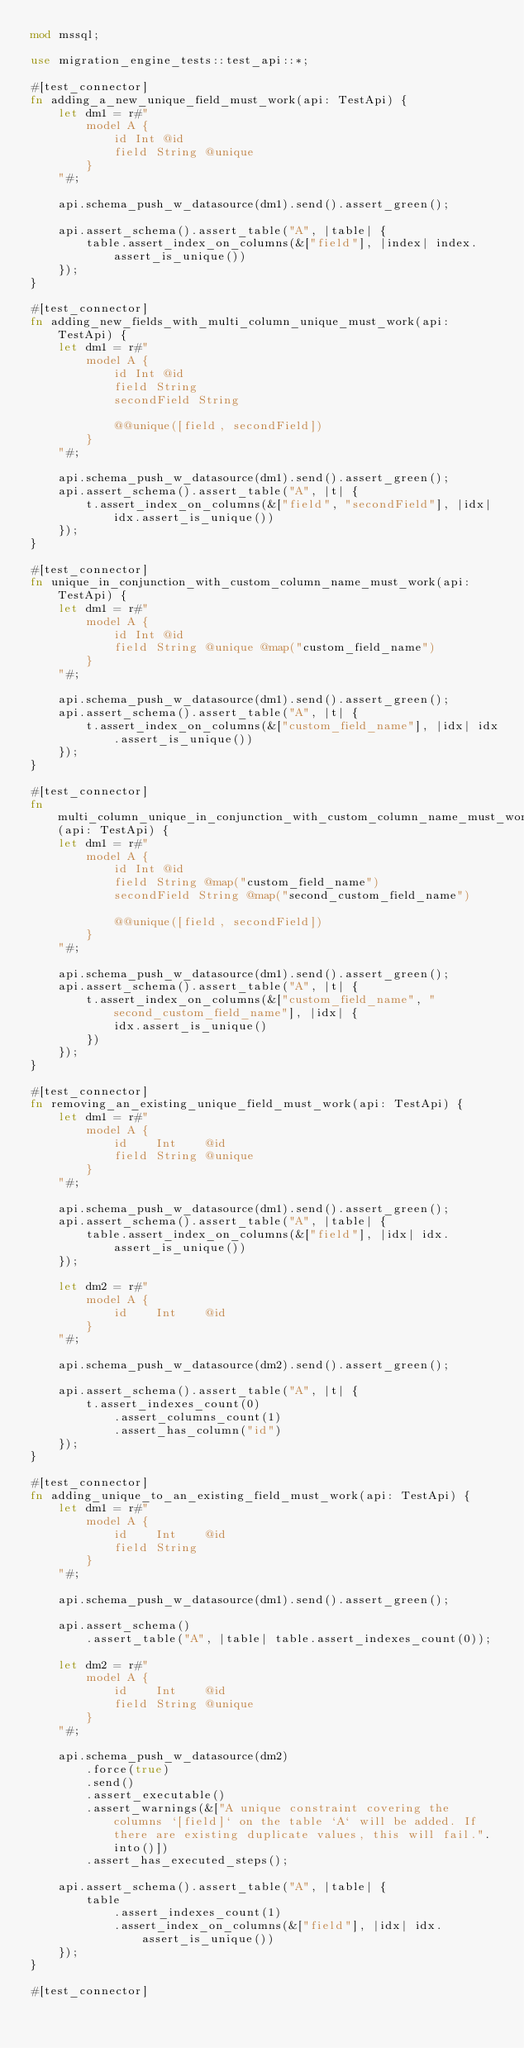Convert code to text. <code><loc_0><loc_0><loc_500><loc_500><_Rust_>mod mssql;

use migration_engine_tests::test_api::*;

#[test_connector]
fn adding_a_new_unique_field_must_work(api: TestApi) {
    let dm1 = r#"
        model A {
            id Int @id
            field String @unique
        }
    "#;

    api.schema_push_w_datasource(dm1).send().assert_green();

    api.assert_schema().assert_table("A", |table| {
        table.assert_index_on_columns(&["field"], |index| index.assert_is_unique())
    });
}

#[test_connector]
fn adding_new_fields_with_multi_column_unique_must_work(api: TestApi) {
    let dm1 = r#"
        model A {
            id Int @id
            field String
            secondField String

            @@unique([field, secondField])
        }
    "#;

    api.schema_push_w_datasource(dm1).send().assert_green();
    api.assert_schema().assert_table("A", |t| {
        t.assert_index_on_columns(&["field", "secondField"], |idx| idx.assert_is_unique())
    });
}

#[test_connector]
fn unique_in_conjunction_with_custom_column_name_must_work(api: TestApi) {
    let dm1 = r#"
        model A {
            id Int @id
            field String @unique @map("custom_field_name")
        }
    "#;

    api.schema_push_w_datasource(dm1).send().assert_green();
    api.assert_schema().assert_table("A", |t| {
        t.assert_index_on_columns(&["custom_field_name"], |idx| idx.assert_is_unique())
    });
}

#[test_connector]
fn multi_column_unique_in_conjunction_with_custom_column_name_must_work(api: TestApi) {
    let dm1 = r#"
        model A {
            id Int @id
            field String @map("custom_field_name")
            secondField String @map("second_custom_field_name")

            @@unique([field, secondField])
        }
    "#;

    api.schema_push_w_datasource(dm1).send().assert_green();
    api.assert_schema().assert_table("A", |t| {
        t.assert_index_on_columns(&["custom_field_name", "second_custom_field_name"], |idx| {
            idx.assert_is_unique()
        })
    });
}

#[test_connector]
fn removing_an_existing_unique_field_must_work(api: TestApi) {
    let dm1 = r#"
        model A {
            id    Int    @id
            field String @unique
        }
    "#;

    api.schema_push_w_datasource(dm1).send().assert_green();
    api.assert_schema().assert_table("A", |table| {
        table.assert_index_on_columns(&["field"], |idx| idx.assert_is_unique())
    });

    let dm2 = r#"
        model A {
            id    Int    @id
        }
    "#;

    api.schema_push_w_datasource(dm2).send().assert_green();

    api.assert_schema().assert_table("A", |t| {
        t.assert_indexes_count(0)
            .assert_columns_count(1)
            .assert_has_column("id")
    });
}

#[test_connector]
fn adding_unique_to_an_existing_field_must_work(api: TestApi) {
    let dm1 = r#"
        model A {
            id    Int    @id
            field String
        }
    "#;

    api.schema_push_w_datasource(dm1).send().assert_green();

    api.assert_schema()
        .assert_table("A", |table| table.assert_indexes_count(0));

    let dm2 = r#"
        model A {
            id    Int    @id
            field String @unique
        }
    "#;

    api.schema_push_w_datasource(dm2)
        .force(true)
        .send()
        .assert_executable()
        .assert_warnings(&["A unique constraint covering the columns `[field]` on the table `A` will be added. If there are existing duplicate values, this will fail.".into()])
        .assert_has_executed_steps();

    api.assert_schema().assert_table("A", |table| {
        table
            .assert_indexes_count(1)
            .assert_index_on_columns(&["field"], |idx| idx.assert_is_unique())
    });
}

#[test_connector]</code> 